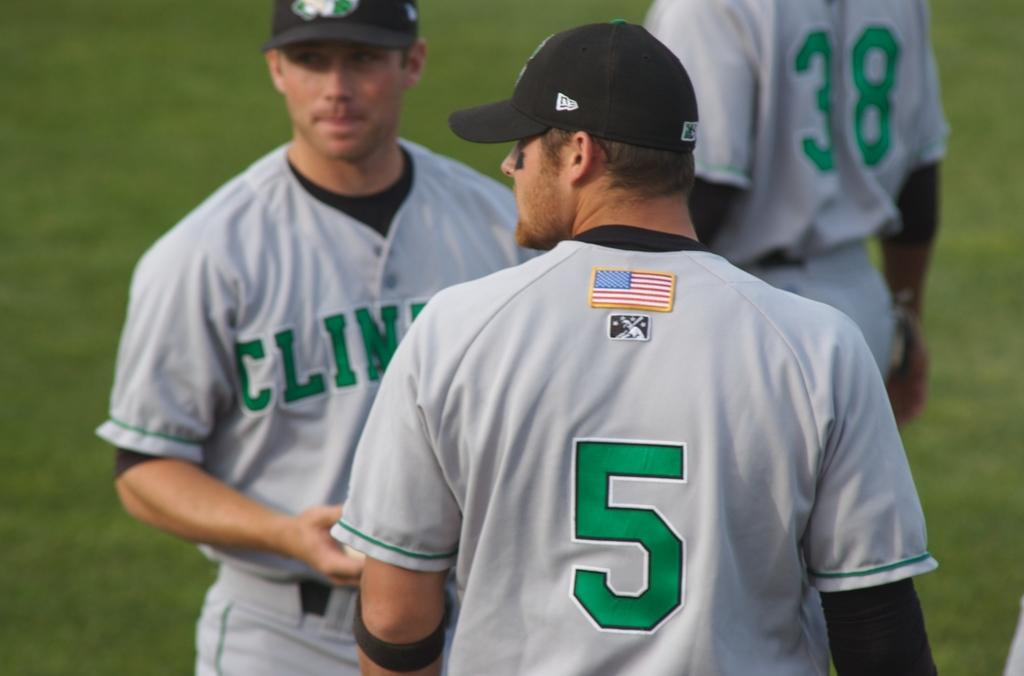<image>
Offer a succinct explanation of the picture presented. Player number 5 stands with a couple of other players on his team. 